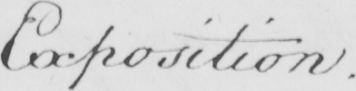Transcribe the text shown in this historical manuscript line. Exposition . 